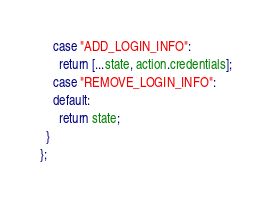<code> <loc_0><loc_0><loc_500><loc_500><_JavaScript_>    case "ADD_LOGIN_INFO":
      return [...state, action.credentials];
    case "REMOVE_LOGIN_INFO":
    default:
      return state;
  }
};
</code> 